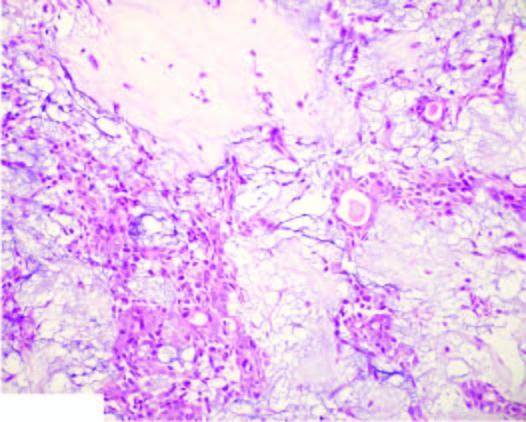what is comprised of ducts, acini, tubules, sheets and strands of cuboidal and myoepithelial cells?
Answer the question using a single word or phrase. Epithelial element 